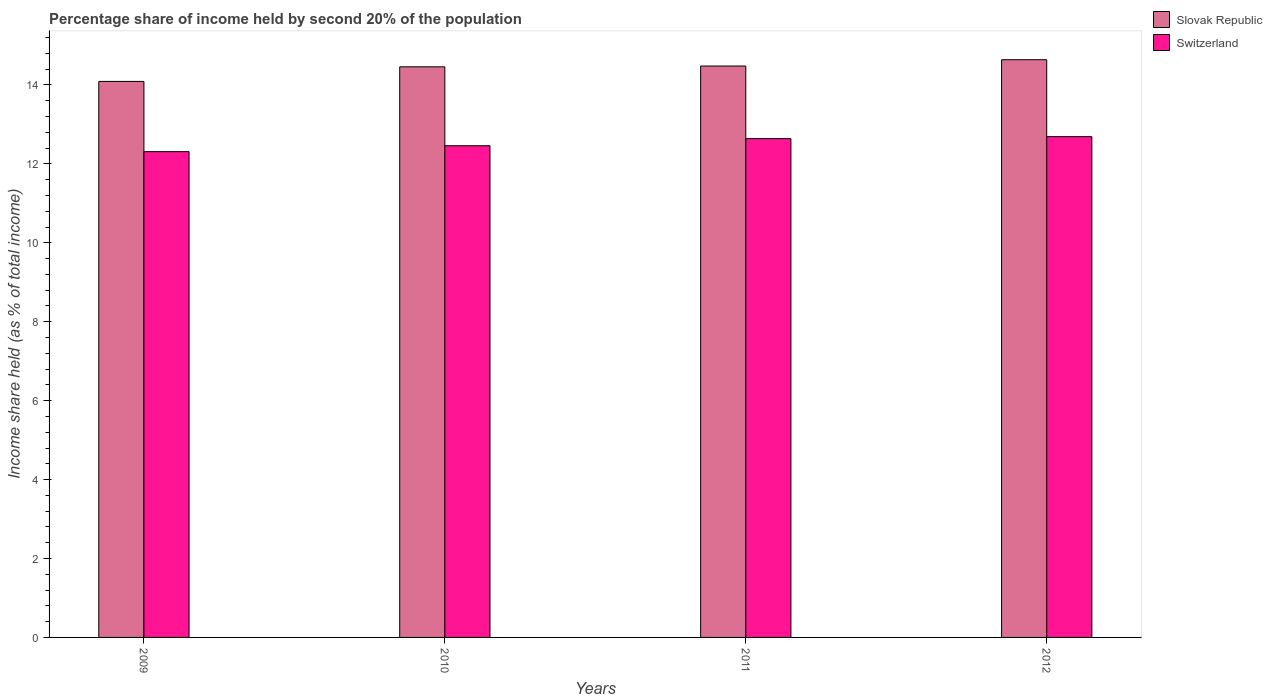How many groups of bars are there?
Offer a very short reply. 4. Are the number of bars per tick equal to the number of legend labels?
Provide a short and direct response. Yes. In how many cases, is the number of bars for a given year not equal to the number of legend labels?
Your answer should be very brief. 0. What is the share of income held by second 20% of the population in Slovak Republic in 2009?
Offer a terse response. 14.09. Across all years, what is the maximum share of income held by second 20% of the population in Switzerland?
Offer a terse response. 12.69. Across all years, what is the minimum share of income held by second 20% of the population in Slovak Republic?
Your response must be concise. 14.09. In which year was the share of income held by second 20% of the population in Slovak Republic maximum?
Provide a succinct answer. 2012. What is the total share of income held by second 20% of the population in Slovak Republic in the graph?
Provide a short and direct response. 57.67. What is the difference between the share of income held by second 20% of the population in Slovak Republic in 2009 and that in 2011?
Your answer should be compact. -0.39. What is the difference between the share of income held by second 20% of the population in Slovak Republic in 2011 and the share of income held by second 20% of the population in Switzerland in 2012?
Offer a very short reply. 1.79. What is the average share of income held by second 20% of the population in Switzerland per year?
Ensure brevity in your answer.  12.53. In the year 2009, what is the difference between the share of income held by second 20% of the population in Switzerland and share of income held by second 20% of the population in Slovak Republic?
Your answer should be compact. -1.78. What is the ratio of the share of income held by second 20% of the population in Slovak Republic in 2009 to that in 2010?
Give a very brief answer. 0.97. Is the share of income held by second 20% of the population in Switzerland in 2009 less than that in 2010?
Keep it short and to the point. Yes. What is the difference between the highest and the second highest share of income held by second 20% of the population in Slovak Republic?
Make the answer very short. 0.16. What is the difference between the highest and the lowest share of income held by second 20% of the population in Switzerland?
Give a very brief answer. 0.38. In how many years, is the share of income held by second 20% of the population in Switzerland greater than the average share of income held by second 20% of the population in Switzerland taken over all years?
Ensure brevity in your answer.  2. Is the sum of the share of income held by second 20% of the population in Switzerland in 2009 and 2012 greater than the maximum share of income held by second 20% of the population in Slovak Republic across all years?
Ensure brevity in your answer.  Yes. What does the 2nd bar from the left in 2011 represents?
Offer a terse response. Switzerland. What does the 1st bar from the right in 2011 represents?
Your response must be concise. Switzerland. How many bars are there?
Offer a very short reply. 8. Are all the bars in the graph horizontal?
Ensure brevity in your answer.  No. How many years are there in the graph?
Ensure brevity in your answer.  4. Does the graph contain grids?
Your answer should be very brief. No. How are the legend labels stacked?
Your response must be concise. Vertical. What is the title of the graph?
Your answer should be compact. Percentage share of income held by second 20% of the population. What is the label or title of the X-axis?
Keep it short and to the point. Years. What is the label or title of the Y-axis?
Provide a succinct answer. Income share held (as % of total income). What is the Income share held (as % of total income) in Slovak Republic in 2009?
Make the answer very short. 14.09. What is the Income share held (as % of total income) in Switzerland in 2009?
Ensure brevity in your answer.  12.31. What is the Income share held (as % of total income) in Slovak Republic in 2010?
Provide a succinct answer. 14.46. What is the Income share held (as % of total income) in Switzerland in 2010?
Ensure brevity in your answer.  12.46. What is the Income share held (as % of total income) in Slovak Republic in 2011?
Your answer should be very brief. 14.48. What is the Income share held (as % of total income) of Switzerland in 2011?
Offer a very short reply. 12.64. What is the Income share held (as % of total income) of Slovak Republic in 2012?
Make the answer very short. 14.64. What is the Income share held (as % of total income) in Switzerland in 2012?
Provide a succinct answer. 12.69. Across all years, what is the maximum Income share held (as % of total income) of Slovak Republic?
Keep it short and to the point. 14.64. Across all years, what is the maximum Income share held (as % of total income) of Switzerland?
Your answer should be very brief. 12.69. Across all years, what is the minimum Income share held (as % of total income) of Slovak Republic?
Ensure brevity in your answer.  14.09. Across all years, what is the minimum Income share held (as % of total income) in Switzerland?
Provide a short and direct response. 12.31. What is the total Income share held (as % of total income) of Slovak Republic in the graph?
Your response must be concise. 57.67. What is the total Income share held (as % of total income) in Switzerland in the graph?
Offer a terse response. 50.1. What is the difference between the Income share held (as % of total income) of Slovak Republic in 2009 and that in 2010?
Provide a succinct answer. -0.37. What is the difference between the Income share held (as % of total income) of Slovak Republic in 2009 and that in 2011?
Your answer should be very brief. -0.39. What is the difference between the Income share held (as % of total income) in Switzerland in 2009 and that in 2011?
Keep it short and to the point. -0.33. What is the difference between the Income share held (as % of total income) in Slovak Republic in 2009 and that in 2012?
Your response must be concise. -0.55. What is the difference between the Income share held (as % of total income) of Switzerland in 2009 and that in 2012?
Provide a succinct answer. -0.38. What is the difference between the Income share held (as % of total income) of Slovak Republic in 2010 and that in 2011?
Provide a short and direct response. -0.02. What is the difference between the Income share held (as % of total income) in Switzerland in 2010 and that in 2011?
Provide a short and direct response. -0.18. What is the difference between the Income share held (as % of total income) of Slovak Republic in 2010 and that in 2012?
Provide a succinct answer. -0.18. What is the difference between the Income share held (as % of total income) of Switzerland in 2010 and that in 2012?
Your response must be concise. -0.23. What is the difference between the Income share held (as % of total income) of Slovak Republic in 2011 and that in 2012?
Your answer should be very brief. -0.16. What is the difference between the Income share held (as % of total income) in Switzerland in 2011 and that in 2012?
Make the answer very short. -0.05. What is the difference between the Income share held (as % of total income) of Slovak Republic in 2009 and the Income share held (as % of total income) of Switzerland in 2010?
Your response must be concise. 1.63. What is the difference between the Income share held (as % of total income) of Slovak Republic in 2009 and the Income share held (as % of total income) of Switzerland in 2011?
Provide a succinct answer. 1.45. What is the difference between the Income share held (as % of total income) in Slovak Republic in 2010 and the Income share held (as % of total income) in Switzerland in 2011?
Offer a terse response. 1.82. What is the difference between the Income share held (as % of total income) in Slovak Republic in 2010 and the Income share held (as % of total income) in Switzerland in 2012?
Make the answer very short. 1.77. What is the difference between the Income share held (as % of total income) in Slovak Republic in 2011 and the Income share held (as % of total income) in Switzerland in 2012?
Make the answer very short. 1.79. What is the average Income share held (as % of total income) in Slovak Republic per year?
Provide a succinct answer. 14.42. What is the average Income share held (as % of total income) of Switzerland per year?
Ensure brevity in your answer.  12.53. In the year 2009, what is the difference between the Income share held (as % of total income) in Slovak Republic and Income share held (as % of total income) in Switzerland?
Offer a very short reply. 1.78. In the year 2011, what is the difference between the Income share held (as % of total income) of Slovak Republic and Income share held (as % of total income) of Switzerland?
Provide a short and direct response. 1.84. In the year 2012, what is the difference between the Income share held (as % of total income) in Slovak Republic and Income share held (as % of total income) in Switzerland?
Provide a succinct answer. 1.95. What is the ratio of the Income share held (as % of total income) of Slovak Republic in 2009 to that in 2010?
Provide a short and direct response. 0.97. What is the ratio of the Income share held (as % of total income) in Slovak Republic in 2009 to that in 2011?
Give a very brief answer. 0.97. What is the ratio of the Income share held (as % of total income) of Switzerland in 2009 to that in 2011?
Provide a short and direct response. 0.97. What is the ratio of the Income share held (as % of total income) of Slovak Republic in 2009 to that in 2012?
Your answer should be very brief. 0.96. What is the ratio of the Income share held (as % of total income) of Switzerland in 2009 to that in 2012?
Offer a terse response. 0.97. What is the ratio of the Income share held (as % of total income) in Slovak Republic in 2010 to that in 2011?
Your answer should be compact. 1. What is the ratio of the Income share held (as % of total income) of Switzerland in 2010 to that in 2011?
Keep it short and to the point. 0.99. What is the ratio of the Income share held (as % of total income) in Switzerland in 2010 to that in 2012?
Offer a terse response. 0.98. What is the ratio of the Income share held (as % of total income) in Slovak Republic in 2011 to that in 2012?
Ensure brevity in your answer.  0.99. What is the difference between the highest and the second highest Income share held (as % of total income) of Slovak Republic?
Keep it short and to the point. 0.16. What is the difference between the highest and the second highest Income share held (as % of total income) in Switzerland?
Offer a terse response. 0.05. What is the difference between the highest and the lowest Income share held (as % of total income) of Slovak Republic?
Offer a terse response. 0.55. What is the difference between the highest and the lowest Income share held (as % of total income) of Switzerland?
Make the answer very short. 0.38. 